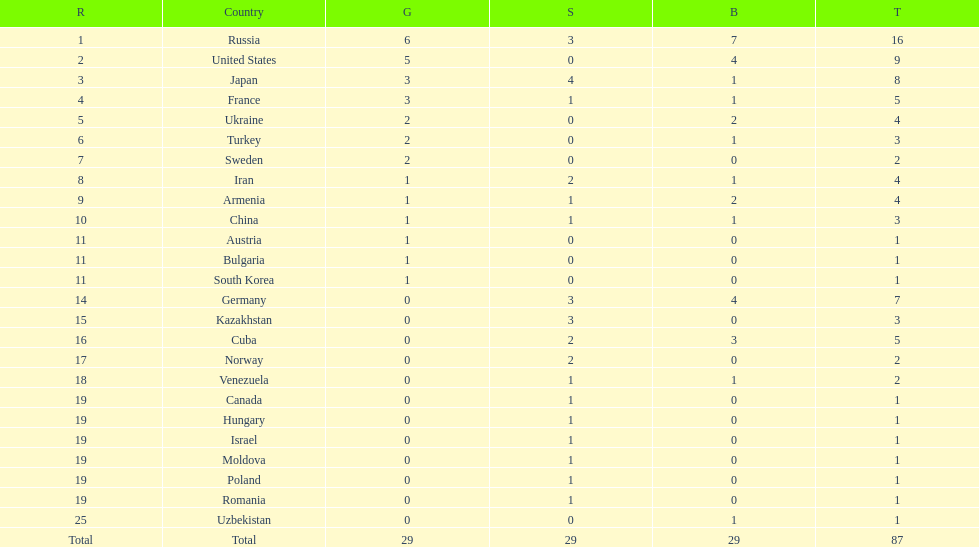Would you mind parsing the complete table? {'header': ['R', 'Country', 'G', 'S', 'B', 'T'], 'rows': [['1', 'Russia', '6', '3', '7', '16'], ['2', 'United States', '5', '0', '4', '9'], ['3', 'Japan', '3', '4', '1', '8'], ['4', 'France', '3', '1', '1', '5'], ['5', 'Ukraine', '2', '0', '2', '4'], ['6', 'Turkey', '2', '0', '1', '3'], ['7', 'Sweden', '2', '0', '0', '2'], ['8', 'Iran', '1', '2', '1', '4'], ['9', 'Armenia', '1', '1', '2', '4'], ['10', 'China', '1', '1', '1', '3'], ['11', 'Austria', '1', '0', '0', '1'], ['11', 'Bulgaria', '1', '0', '0', '1'], ['11', 'South Korea', '1', '0', '0', '1'], ['14', 'Germany', '0', '3', '4', '7'], ['15', 'Kazakhstan', '0', '3', '0', '3'], ['16', 'Cuba', '0', '2', '3', '5'], ['17', 'Norway', '0', '2', '0', '2'], ['18', 'Venezuela', '0', '1', '1', '2'], ['19', 'Canada', '0', '1', '0', '1'], ['19', 'Hungary', '0', '1', '0', '1'], ['19', 'Israel', '0', '1', '0', '1'], ['19', 'Moldova', '0', '1', '0', '1'], ['19', 'Poland', '0', '1', '0', '1'], ['19', 'Romania', '0', '1', '0', '1'], ['25', 'Uzbekistan', '0', '0', '1', '1'], ['Total', 'Total', '29', '29', '29', '87']]} Which nation took home the highest medal count? Russia. 